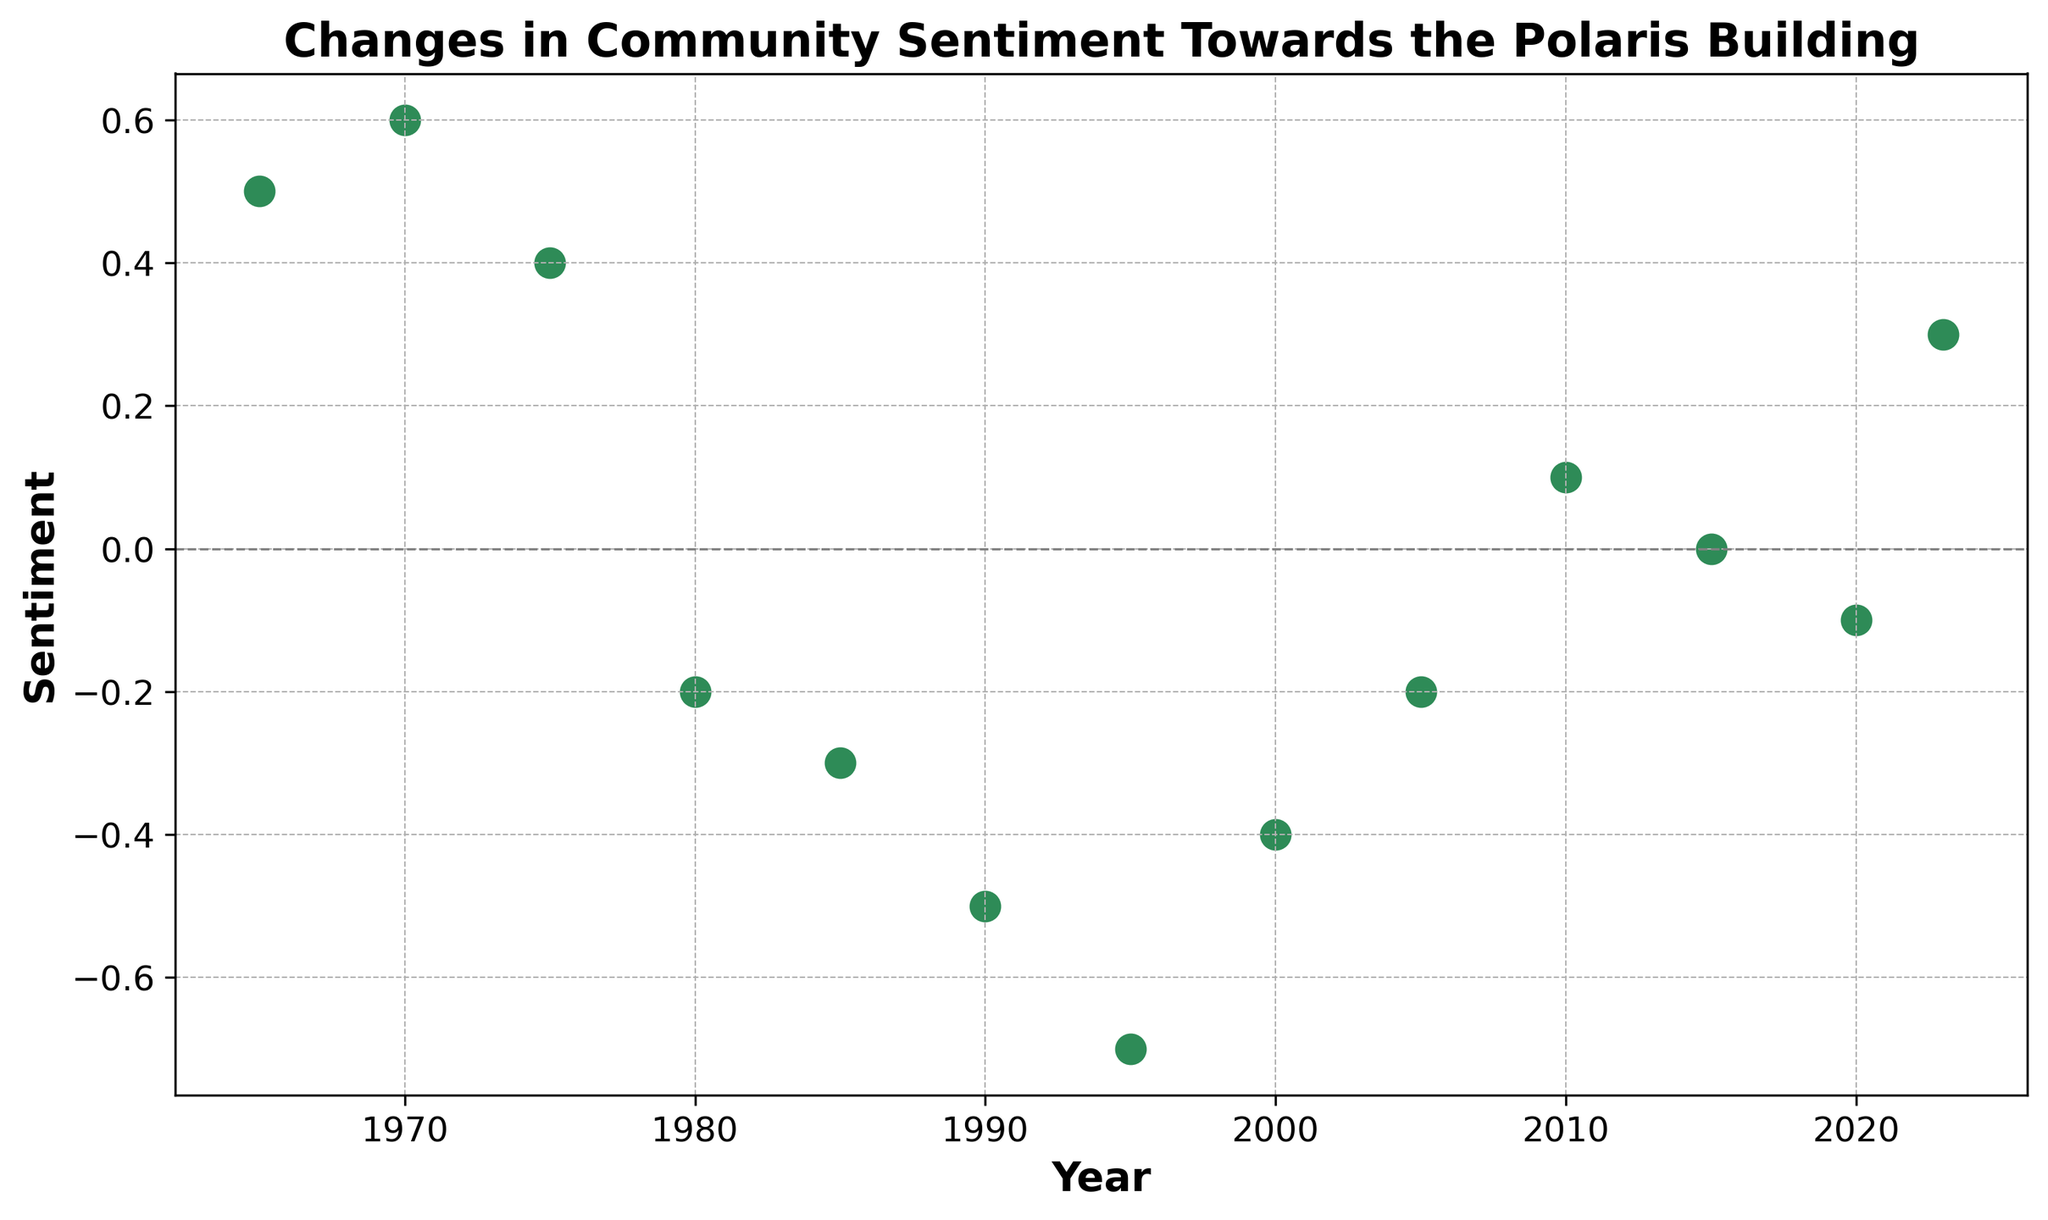How does the sentiment trend shift between 1980 and 2000? Visually observe the scatter plot and note that sentiment starts at -0.2 in 1980, drops to -0.5 in 1990, reaches its lowest point at -0.7 in 1995, and then improves to -0.4 by 2000. The overall trend is a decline followed by a slight recovery.
Answer: Decline followed by slight recovery Between which decades did the sentiment decline the most sharply? By comparing the differences in sentiment between each decade visually, identify that the sentiment dropped from 0.4 in 1975 to -0.2 in 1980, showing the sharpest decline of 0.6.
Answer: 1975 to 1980 What is the general trend in community sentiment towards the Polaris Building from 1965 to 2023? Examining the scatter plot from left to right, observe the overall pattern: an initial increase until 1970, a significant decline until 1995, and then some recovery towards 2023. The general trend is a decline followed by some improvement.
Answer: Decline followed by improvement Which decade shows the first instance of negative sentiment? Visual inspection of the sentiment values reveals that the first instance of negative sentiment occurs in 1980, as indicated by the -0.2 sentiment value.
Answer: 1980 What is the difference in sentiment between the highest and lowest points? Visually identify the highest sentiment at 0.6 (in 1970) and the lowest sentiment at -0.7 (in 1995). The difference is calculated as 0.6 - (-0.7) = 1.3.
Answer: 1.3 Between which two non-consecutive years did the sentiment change by the largest amount? By comparing sentiment changes over non-consecutive years, observe the change from 1995 (-0.7) to 2023 (0.3), with a total change of 0.7 + 0.3 = 1.0.
Answer: 1995 to 2023 Why is there a horizontal line at y=0 on the scatter plot? The horizontal line at y=0 serves as a reference to differentiate between positive and negative sentiment, thereby helping to visually separate periods of positive feeling from those with negative sentiment.
Answer: Reference line for sentiment Which years show a positive sentiment? Checking the points above the horizontal line (y=0) on the scatter plot, note that 1965, 1970, 1975, 2010, and 2023 show positive sentiment values.
Answer: 1965, 1970, 1975, 2010, 2023 